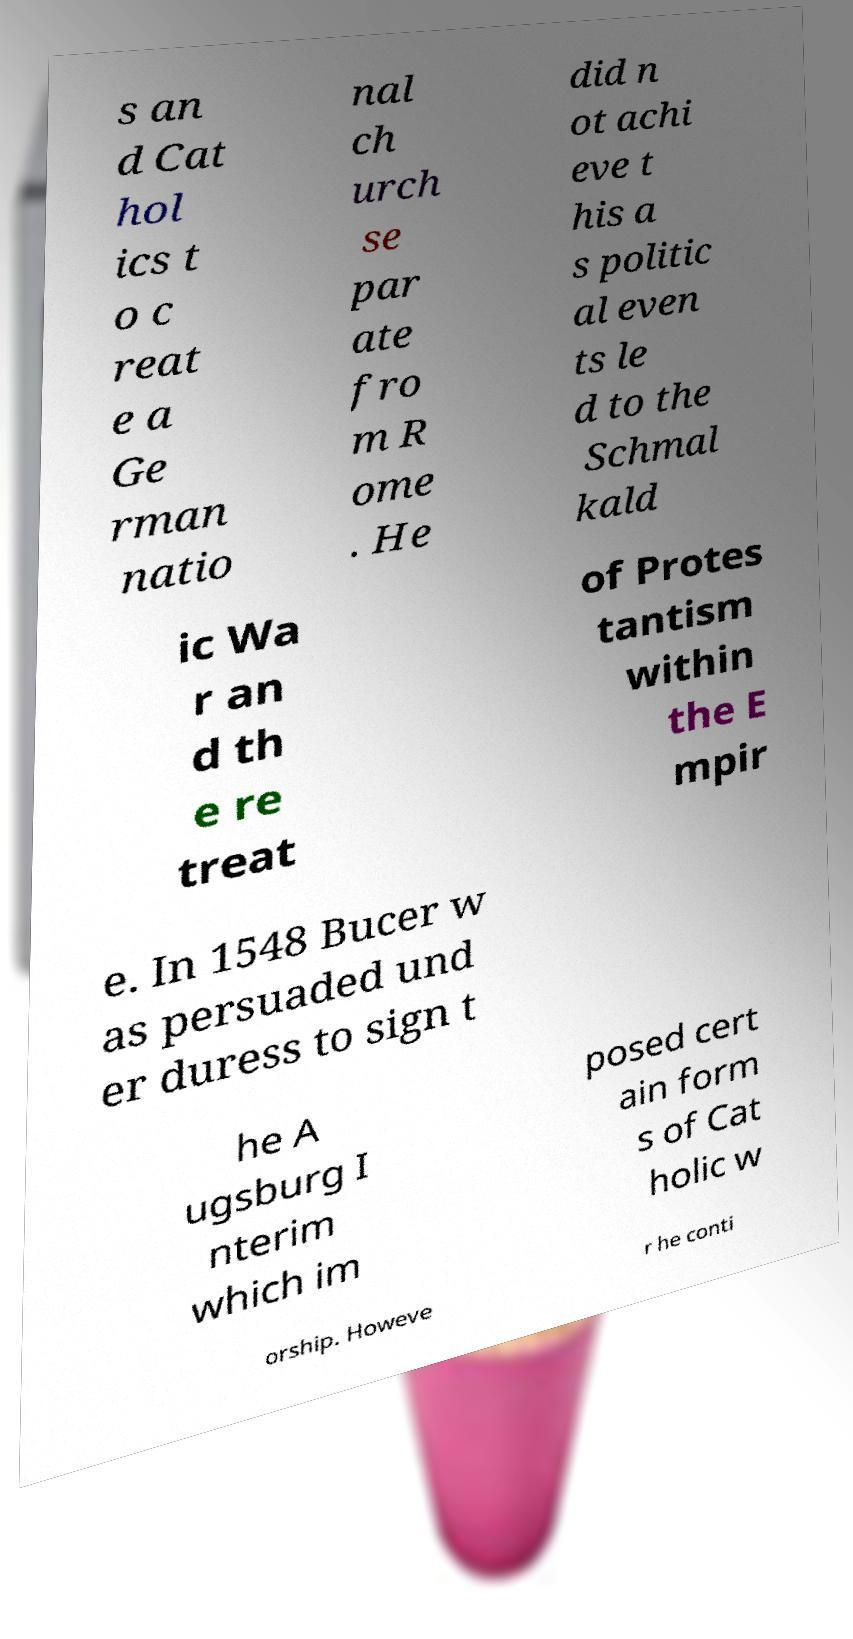There's text embedded in this image that I need extracted. Can you transcribe it verbatim? s an d Cat hol ics t o c reat e a Ge rman natio nal ch urch se par ate fro m R ome . He did n ot achi eve t his a s politic al even ts le d to the Schmal kald ic Wa r an d th e re treat of Protes tantism within the E mpir e. In 1548 Bucer w as persuaded und er duress to sign t he A ugsburg I nterim which im posed cert ain form s of Cat holic w orship. Howeve r he conti 